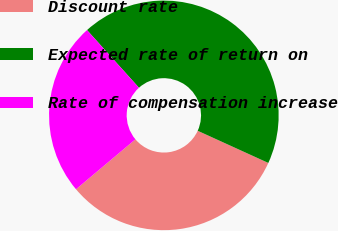<chart> <loc_0><loc_0><loc_500><loc_500><pie_chart><fcel>Discount rate<fcel>Expected rate of return on<fcel>Rate of compensation increase<nl><fcel>32.07%<fcel>43.48%<fcel>24.46%<nl></chart> 